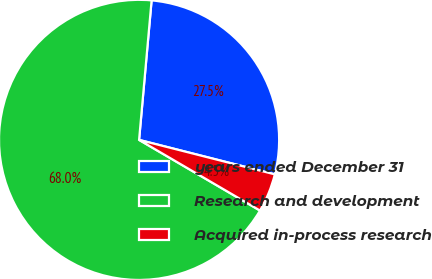<chart> <loc_0><loc_0><loc_500><loc_500><pie_chart><fcel>years ended December 31<fcel>Research and development<fcel>Acquired in-process research<nl><fcel>27.53%<fcel>68.0%<fcel>4.46%<nl></chart> 